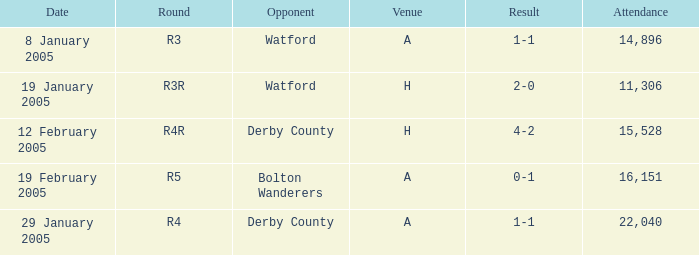What is the date where the round is R3? 8 January 2005. 